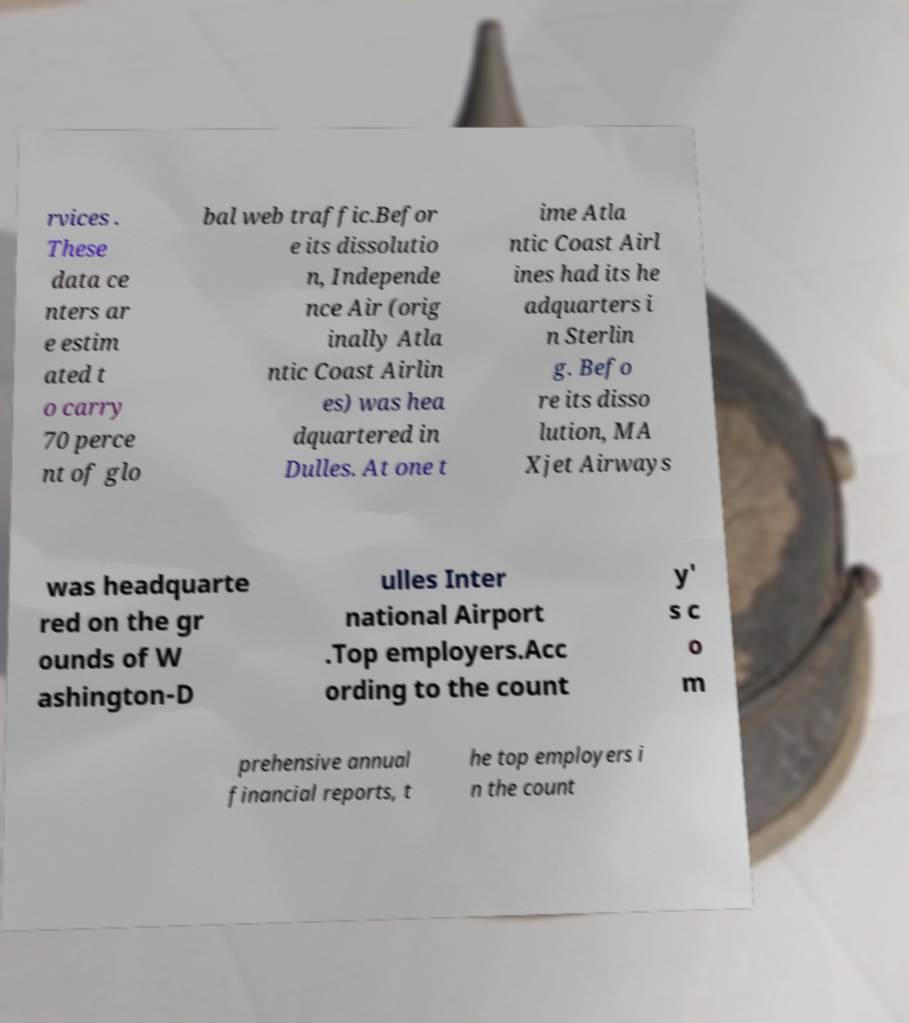I need the written content from this picture converted into text. Can you do that? rvices . These data ce nters ar e estim ated t o carry 70 perce nt of glo bal web traffic.Befor e its dissolutio n, Independe nce Air (orig inally Atla ntic Coast Airlin es) was hea dquartered in Dulles. At one t ime Atla ntic Coast Airl ines had its he adquarters i n Sterlin g. Befo re its disso lution, MA Xjet Airways was headquarte red on the gr ounds of W ashington-D ulles Inter national Airport .Top employers.Acc ording to the count y' s c o m prehensive annual financial reports, t he top employers i n the count 